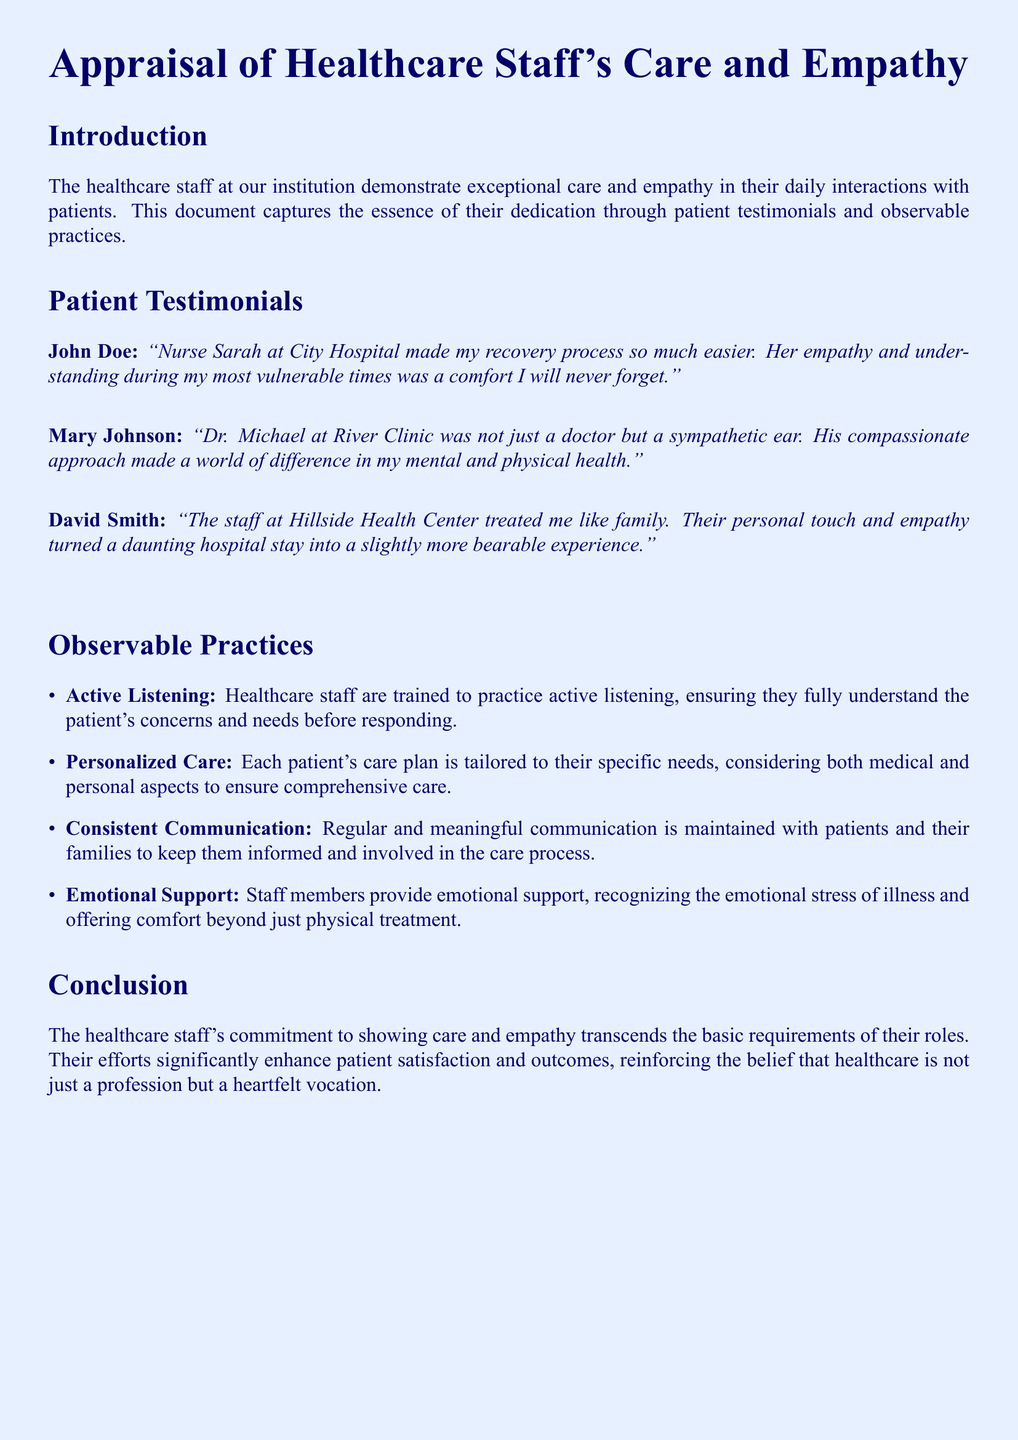What is the title of the document? The title is stated at the beginning of the document and reflects its main focus on assessing care and empathy in healthcare.
Answer: Appraisal of Healthcare Staff's Care and Empathy Who praised Nurse Sarah in their testimonial? The document presents testimonials from various patients, attributing praise to specific staff members.
Answer: John Doe Which healthcare facility is Dr. Michael associated with? The document explicitly mentions the clinics where each doctor or nurse works alongside the patient's testimonial.
Answer: River Clinic What practice involves tailoring care plans to individual needs? The document lists various observable practices that embody the staff's approach to patient care.
Answer: Personalized Care How does the document describe the staff's approach to communication? The document categorizes observable practices with specific terms illustrating how healthcare staff interact with patients and families.
Answer: Consistent Communication What emotional aspect does the healthcare staff recognize during patient care? The text highlights the importance of addressing various emotional facets of patient care, indicating this as a priority in their practices.
Answer: Emotional Support Who felt treated like family during their hospital stay? The document's testimonials provide insights into personal experiences with the healthcare staff, illustrating their impact on patient experiences.
Answer: David Smith What is the effect of healthcare staff's empathy on patient satisfaction? The conclusion of the document emphasizes how the staff's actions influence overall patient satisfaction, connecting to the heart of caregiving.
Answer: Significantly enhance What is the main theme of the conclusion in the document? The conclusion summarizes the core message of the document, reinforcing the dedication of the staff in their roles.
Answer: Commitment to care and empathy 